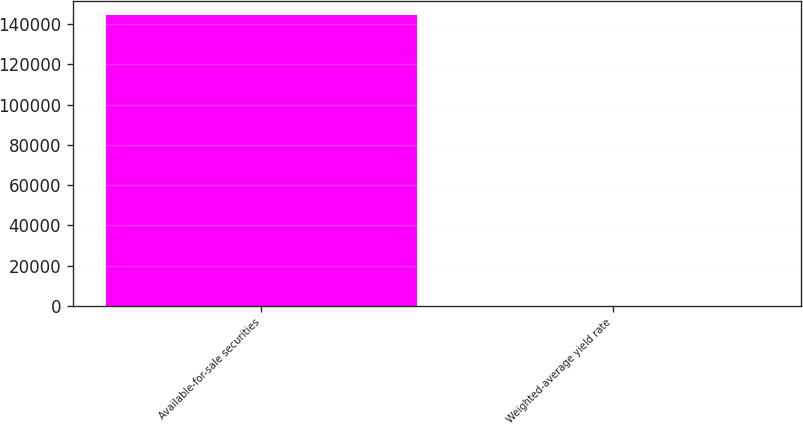Convert chart to OTSL. <chart><loc_0><loc_0><loc_500><loc_500><bar_chart><fcel>Available-for-sale securities<fcel>Weighted-average yield rate<nl><fcel>144328<fcel>0.86<nl></chart> 